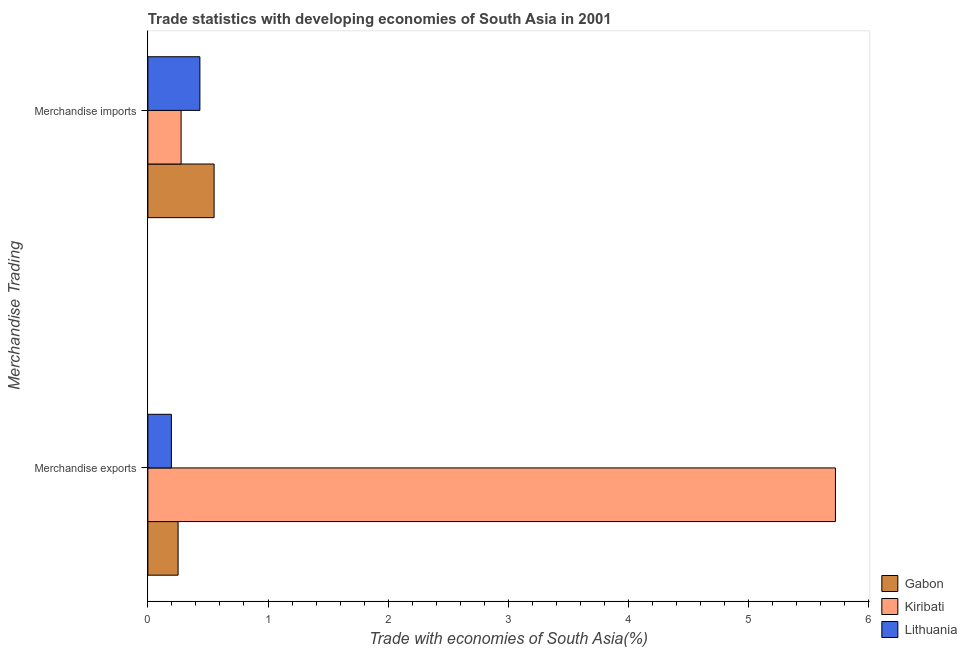Are the number of bars per tick equal to the number of legend labels?
Provide a short and direct response. Yes. How many bars are there on the 2nd tick from the top?
Keep it short and to the point. 3. What is the label of the 1st group of bars from the top?
Your answer should be compact. Merchandise imports. What is the merchandise imports in Lithuania?
Your response must be concise. 0.43. Across all countries, what is the maximum merchandise imports?
Give a very brief answer. 0.55. Across all countries, what is the minimum merchandise exports?
Keep it short and to the point. 0.2. In which country was the merchandise imports maximum?
Make the answer very short. Gabon. In which country was the merchandise exports minimum?
Offer a very short reply. Lithuania. What is the total merchandise imports in the graph?
Your answer should be compact. 1.26. What is the difference between the merchandise imports in Lithuania and that in Gabon?
Your answer should be very brief. -0.12. What is the difference between the merchandise imports in Lithuania and the merchandise exports in Kiribati?
Provide a short and direct response. -5.29. What is the average merchandise exports per country?
Keep it short and to the point. 2.06. What is the difference between the merchandise exports and merchandise imports in Gabon?
Offer a very short reply. -0.3. What is the ratio of the merchandise imports in Gabon to that in Lithuania?
Keep it short and to the point. 1.27. Is the merchandise imports in Lithuania less than that in Kiribati?
Provide a succinct answer. No. In how many countries, is the merchandise exports greater than the average merchandise exports taken over all countries?
Offer a terse response. 1. What does the 3rd bar from the top in Merchandise exports represents?
Your answer should be compact. Gabon. What does the 1st bar from the bottom in Merchandise exports represents?
Provide a short and direct response. Gabon. How many bars are there?
Keep it short and to the point. 6. Are all the bars in the graph horizontal?
Ensure brevity in your answer.  Yes. How many countries are there in the graph?
Offer a terse response. 3. What is the difference between two consecutive major ticks on the X-axis?
Make the answer very short. 1. Are the values on the major ticks of X-axis written in scientific E-notation?
Ensure brevity in your answer.  No. Does the graph contain any zero values?
Offer a very short reply. No. Does the graph contain grids?
Your response must be concise. No. Where does the legend appear in the graph?
Give a very brief answer. Bottom right. How are the legend labels stacked?
Your answer should be very brief. Vertical. What is the title of the graph?
Provide a succinct answer. Trade statistics with developing economies of South Asia in 2001. What is the label or title of the X-axis?
Offer a very short reply. Trade with economies of South Asia(%). What is the label or title of the Y-axis?
Your answer should be compact. Merchandise Trading. What is the Trade with economies of South Asia(%) of Gabon in Merchandise exports?
Ensure brevity in your answer.  0.25. What is the Trade with economies of South Asia(%) of Kiribati in Merchandise exports?
Give a very brief answer. 5.72. What is the Trade with economies of South Asia(%) of Lithuania in Merchandise exports?
Ensure brevity in your answer.  0.2. What is the Trade with economies of South Asia(%) of Gabon in Merchandise imports?
Offer a very short reply. 0.55. What is the Trade with economies of South Asia(%) of Kiribati in Merchandise imports?
Give a very brief answer. 0.28. What is the Trade with economies of South Asia(%) of Lithuania in Merchandise imports?
Provide a succinct answer. 0.43. Across all Merchandise Trading, what is the maximum Trade with economies of South Asia(%) in Gabon?
Your response must be concise. 0.55. Across all Merchandise Trading, what is the maximum Trade with economies of South Asia(%) of Kiribati?
Offer a very short reply. 5.72. Across all Merchandise Trading, what is the maximum Trade with economies of South Asia(%) of Lithuania?
Keep it short and to the point. 0.43. Across all Merchandise Trading, what is the minimum Trade with economies of South Asia(%) in Gabon?
Provide a succinct answer. 0.25. Across all Merchandise Trading, what is the minimum Trade with economies of South Asia(%) of Kiribati?
Make the answer very short. 0.28. Across all Merchandise Trading, what is the minimum Trade with economies of South Asia(%) of Lithuania?
Your answer should be compact. 0.2. What is the total Trade with economies of South Asia(%) of Gabon in the graph?
Your answer should be compact. 0.8. What is the total Trade with economies of South Asia(%) of Lithuania in the graph?
Make the answer very short. 0.63. What is the difference between the Trade with economies of South Asia(%) in Gabon in Merchandise exports and that in Merchandise imports?
Ensure brevity in your answer.  -0.3. What is the difference between the Trade with economies of South Asia(%) of Kiribati in Merchandise exports and that in Merchandise imports?
Your answer should be very brief. 5.45. What is the difference between the Trade with economies of South Asia(%) of Lithuania in Merchandise exports and that in Merchandise imports?
Keep it short and to the point. -0.24. What is the difference between the Trade with economies of South Asia(%) of Gabon in Merchandise exports and the Trade with economies of South Asia(%) of Kiribati in Merchandise imports?
Keep it short and to the point. -0.03. What is the difference between the Trade with economies of South Asia(%) of Gabon in Merchandise exports and the Trade with economies of South Asia(%) of Lithuania in Merchandise imports?
Offer a very short reply. -0.18. What is the difference between the Trade with economies of South Asia(%) in Kiribati in Merchandise exports and the Trade with economies of South Asia(%) in Lithuania in Merchandise imports?
Provide a succinct answer. 5.29. What is the average Trade with economies of South Asia(%) in Gabon per Merchandise Trading?
Provide a succinct answer. 0.4. What is the average Trade with economies of South Asia(%) in Kiribati per Merchandise Trading?
Give a very brief answer. 3. What is the average Trade with economies of South Asia(%) in Lithuania per Merchandise Trading?
Your answer should be compact. 0.31. What is the difference between the Trade with economies of South Asia(%) in Gabon and Trade with economies of South Asia(%) in Kiribati in Merchandise exports?
Give a very brief answer. -5.47. What is the difference between the Trade with economies of South Asia(%) in Gabon and Trade with economies of South Asia(%) in Lithuania in Merchandise exports?
Offer a terse response. 0.06. What is the difference between the Trade with economies of South Asia(%) of Kiribati and Trade with economies of South Asia(%) of Lithuania in Merchandise exports?
Your answer should be very brief. 5.53. What is the difference between the Trade with economies of South Asia(%) in Gabon and Trade with economies of South Asia(%) in Kiribati in Merchandise imports?
Offer a very short reply. 0.27. What is the difference between the Trade with economies of South Asia(%) of Gabon and Trade with economies of South Asia(%) of Lithuania in Merchandise imports?
Ensure brevity in your answer.  0.12. What is the difference between the Trade with economies of South Asia(%) in Kiribati and Trade with economies of South Asia(%) in Lithuania in Merchandise imports?
Your answer should be very brief. -0.16. What is the ratio of the Trade with economies of South Asia(%) in Gabon in Merchandise exports to that in Merchandise imports?
Your answer should be compact. 0.46. What is the ratio of the Trade with economies of South Asia(%) of Kiribati in Merchandise exports to that in Merchandise imports?
Offer a very short reply. 20.69. What is the ratio of the Trade with economies of South Asia(%) in Lithuania in Merchandise exports to that in Merchandise imports?
Offer a very short reply. 0.45. What is the difference between the highest and the second highest Trade with economies of South Asia(%) of Gabon?
Your response must be concise. 0.3. What is the difference between the highest and the second highest Trade with economies of South Asia(%) of Kiribati?
Make the answer very short. 5.45. What is the difference between the highest and the second highest Trade with economies of South Asia(%) in Lithuania?
Your answer should be very brief. 0.24. What is the difference between the highest and the lowest Trade with economies of South Asia(%) of Gabon?
Offer a very short reply. 0.3. What is the difference between the highest and the lowest Trade with economies of South Asia(%) in Kiribati?
Give a very brief answer. 5.45. What is the difference between the highest and the lowest Trade with economies of South Asia(%) of Lithuania?
Offer a terse response. 0.24. 